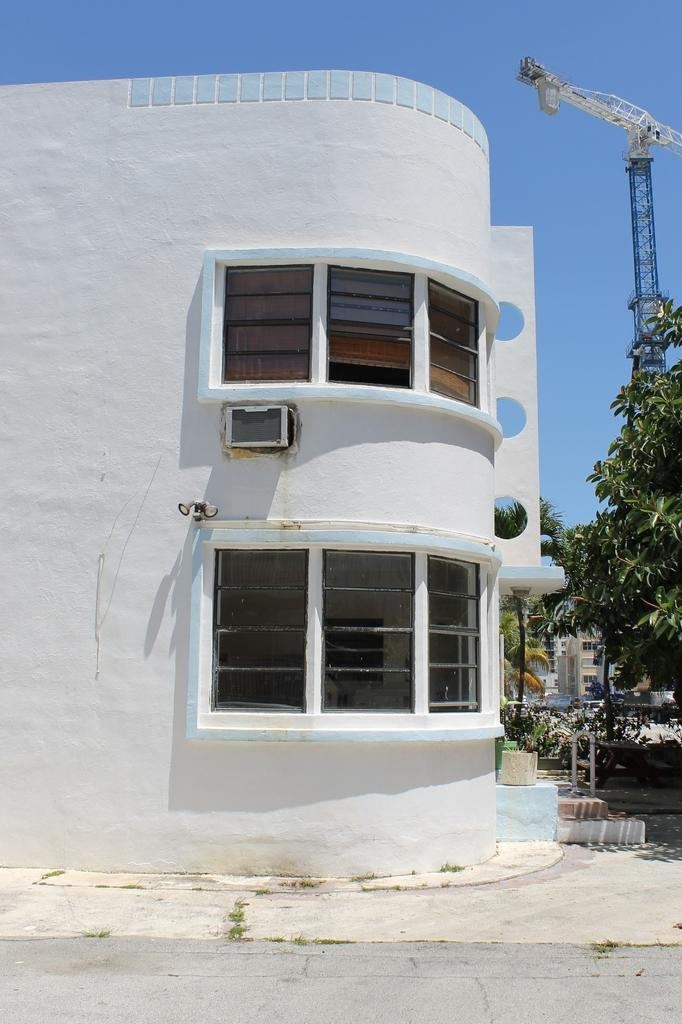What type of structures can be seen in the image? There are buildings in the image. What type of vegetation is present in the image? There are trees in the image. What are the tall, thin objects in the image? There are poles in the image. What is the tall, tower-like structure in the image? There is a tower in the image. What is visible at the top of the image? The sky is visible at the top of the image. What is visible at the bottom of the image? There is a road visible at the bottom of the image. How many hydrants are visible in the image? There are no hydrants present in the image. Can you tell me how many passengers are waiting for the bus in the image? There is no bus or passengers present in the image. 